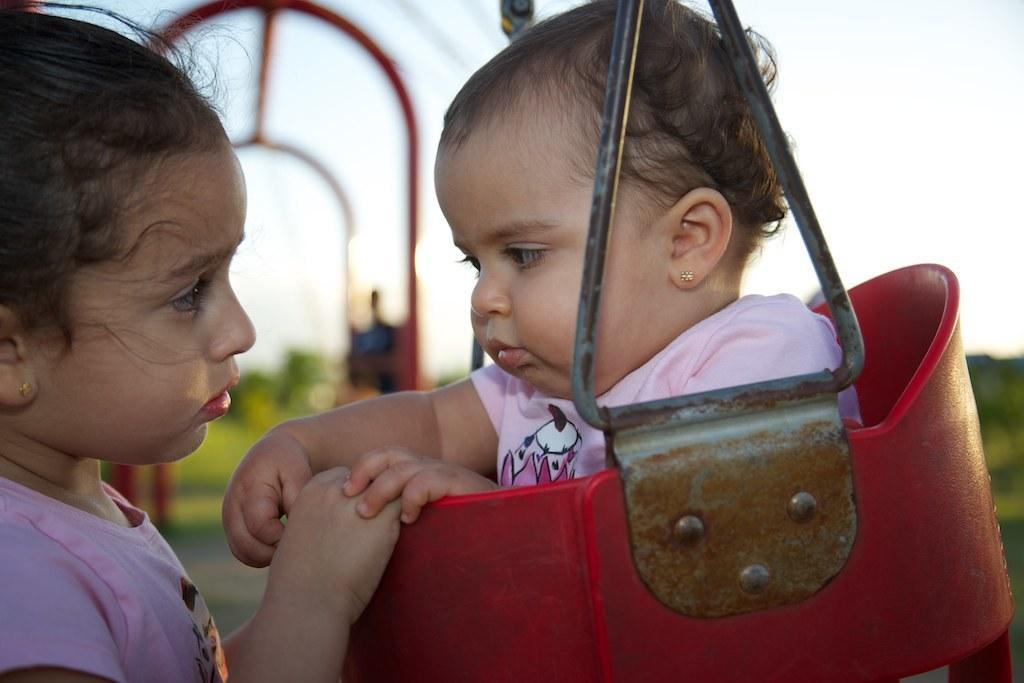Please provide a concise description of this image. There is a baby sitting on a red chair,in front of this baby we can see a girl. In the background it is blurry and we can see sky. 